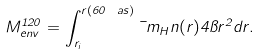<formula> <loc_0><loc_0><loc_500><loc_500>M _ { e n v } ^ { 1 2 0 } = \int _ { r _ { i } } ^ { r ( 6 0 \ a s ) } \mu m _ { H } n ( r ) 4 \pi r ^ { 2 } d r .</formula> 